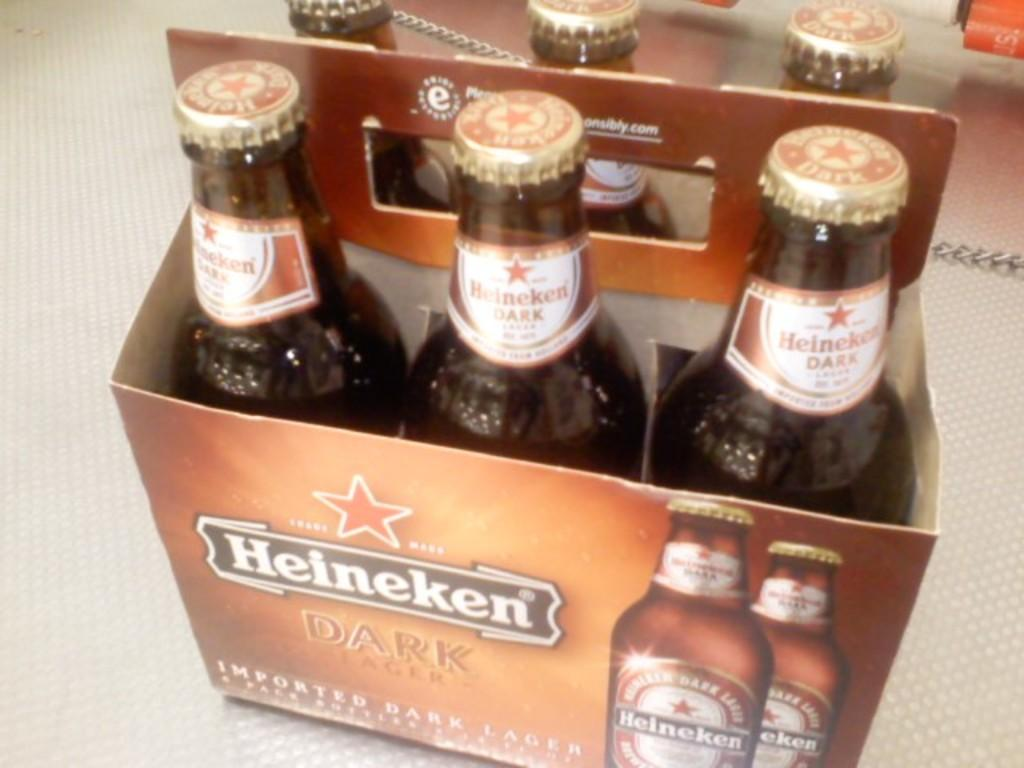<image>
Write a terse but informative summary of the picture. A six pack of unopened Heineken bottles sitting on a table. 